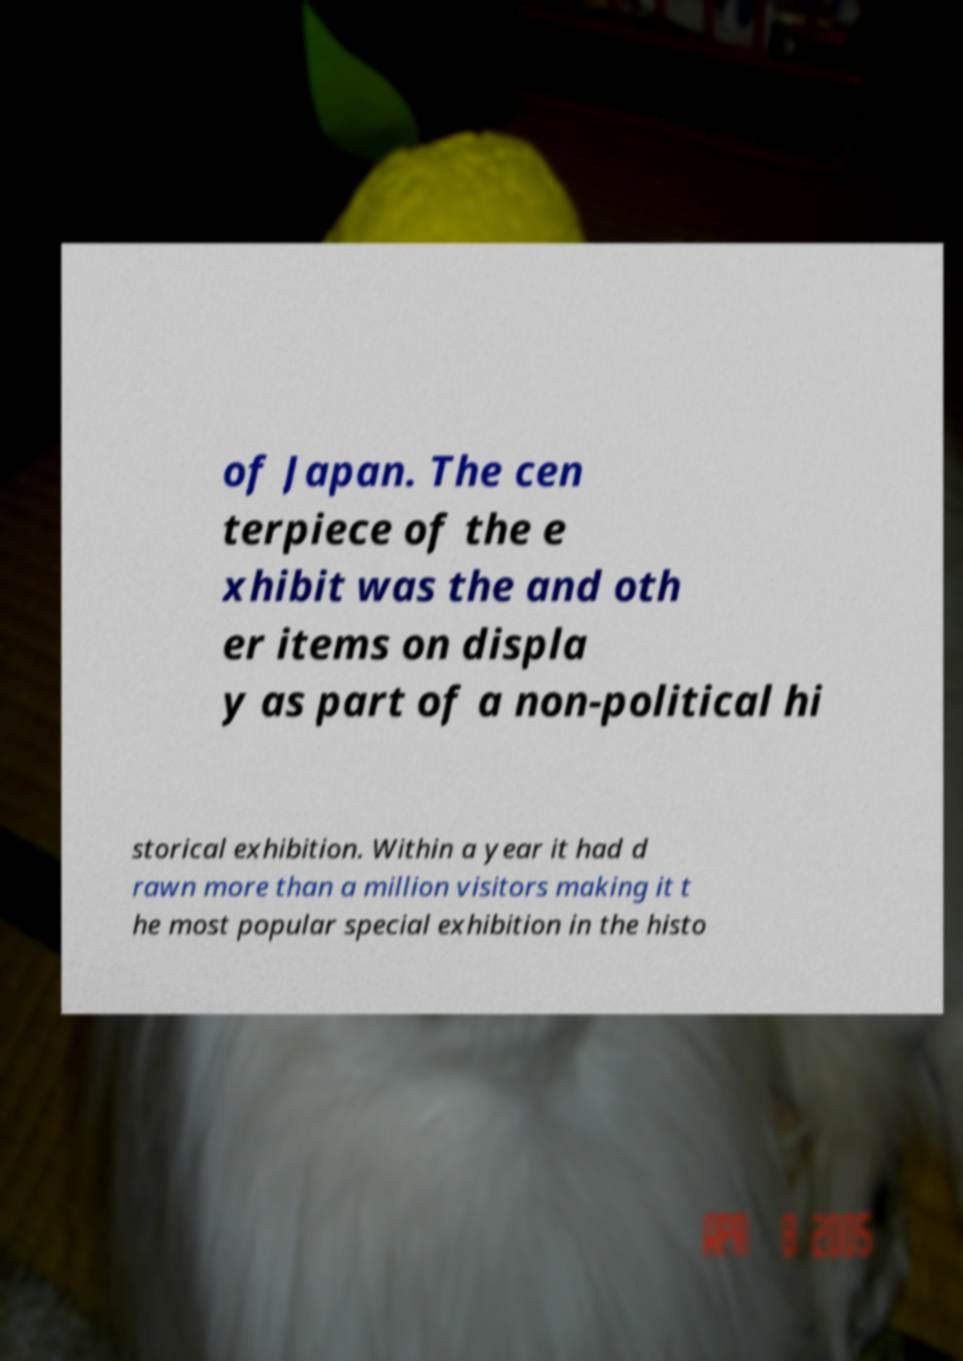Could you extract and type out the text from this image? of Japan. The cen terpiece of the e xhibit was the and oth er items on displa y as part of a non-political hi storical exhibition. Within a year it had d rawn more than a million visitors making it t he most popular special exhibition in the histo 